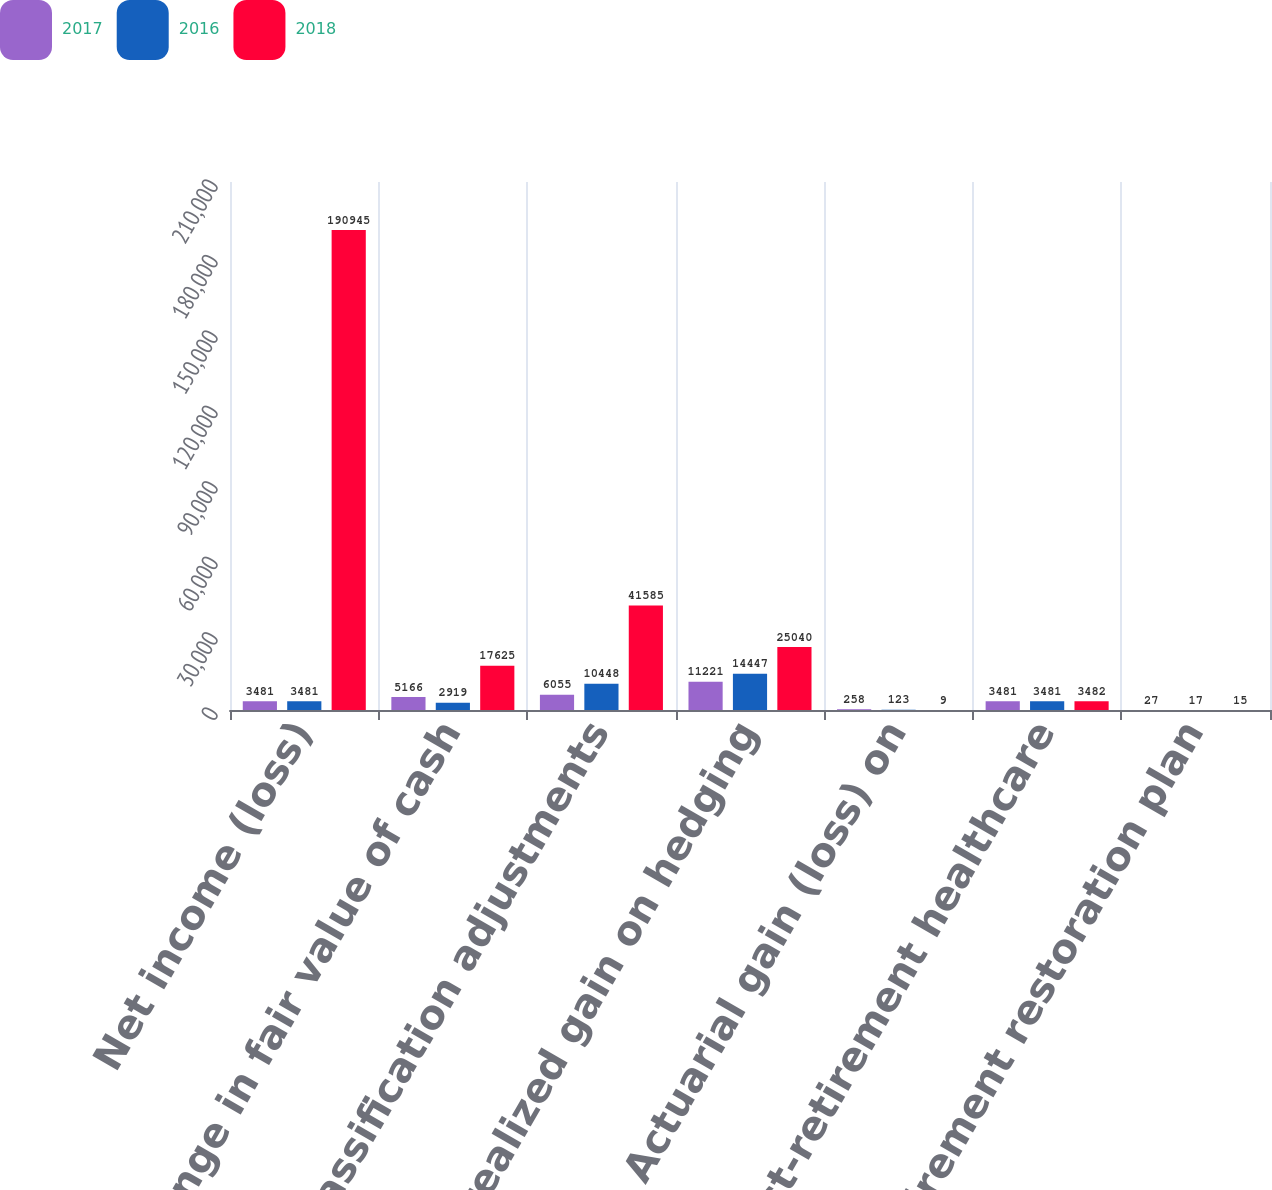Convert chart to OTSL. <chart><loc_0><loc_0><loc_500><loc_500><stacked_bar_chart><ecel><fcel>Net income (loss)<fcel>Change in fair value of cash<fcel>Reclassification adjustments<fcel>Net unrealized gain on hedging<fcel>Actuarial gain (loss) on<fcel>Post-retirement healthcare<fcel>Retirement restoration plan<nl><fcel>2017<fcel>3481<fcel>5166<fcel>6055<fcel>11221<fcel>258<fcel>3481<fcel>27<nl><fcel>2016<fcel>3481<fcel>2919<fcel>10448<fcel>14447<fcel>123<fcel>3481<fcel>17<nl><fcel>2018<fcel>190945<fcel>17625<fcel>41585<fcel>25040<fcel>9<fcel>3482<fcel>15<nl></chart> 